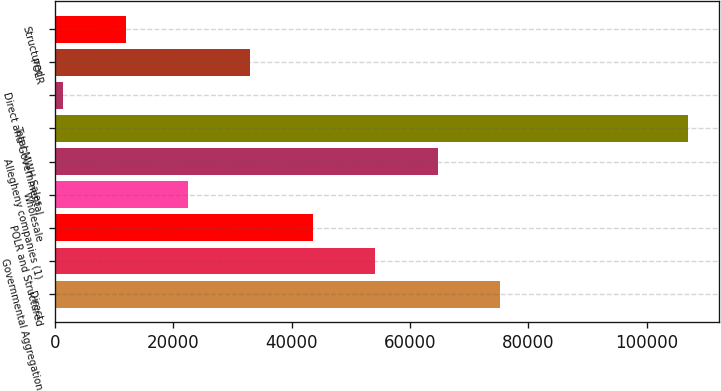Convert chart to OTSL. <chart><loc_0><loc_0><loc_500><loc_500><bar_chart><fcel>Direct<fcel>Governmental Aggregation<fcel>POLR and Structured<fcel>Wholesale<fcel>Allegheny companies (1)<fcel>Total MWH Sales<fcel>Direct and Governmental<fcel>POLR<fcel>Structured<nl><fcel>75244.9<fcel>54143.5<fcel>43592.8<fcel>22491.4<fcel>64694.2<fcel>106897<fcel>1390<fcel>33042.1<fcel>11940.7<nl></chart> 